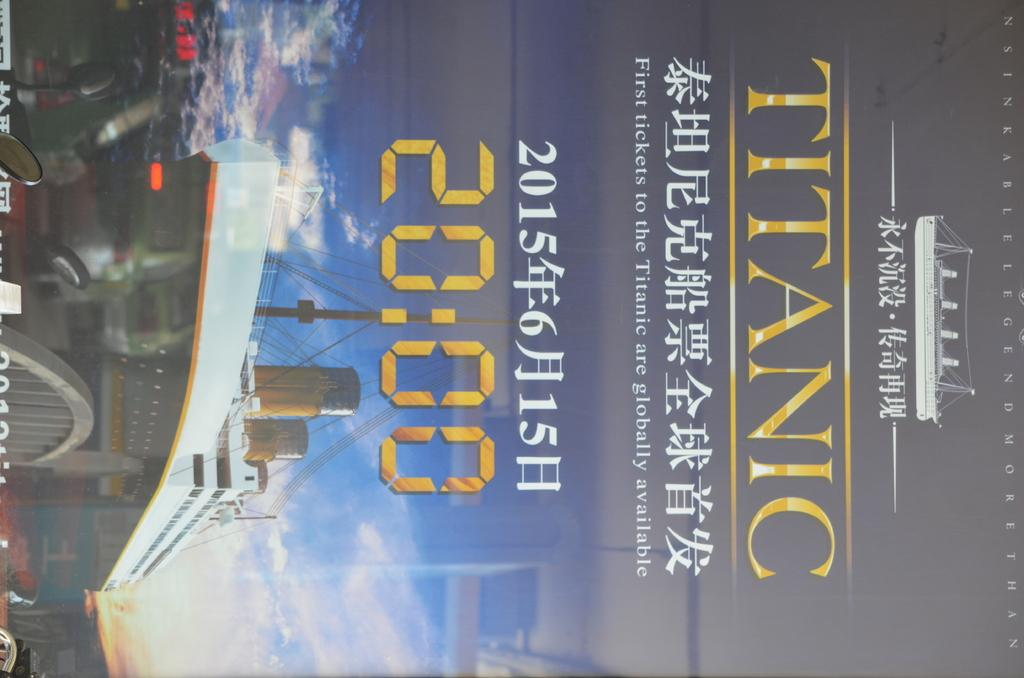Provide a one-sentence caption for the provided image. An Advertisement for tickets to Titanic is written in an asian language. 